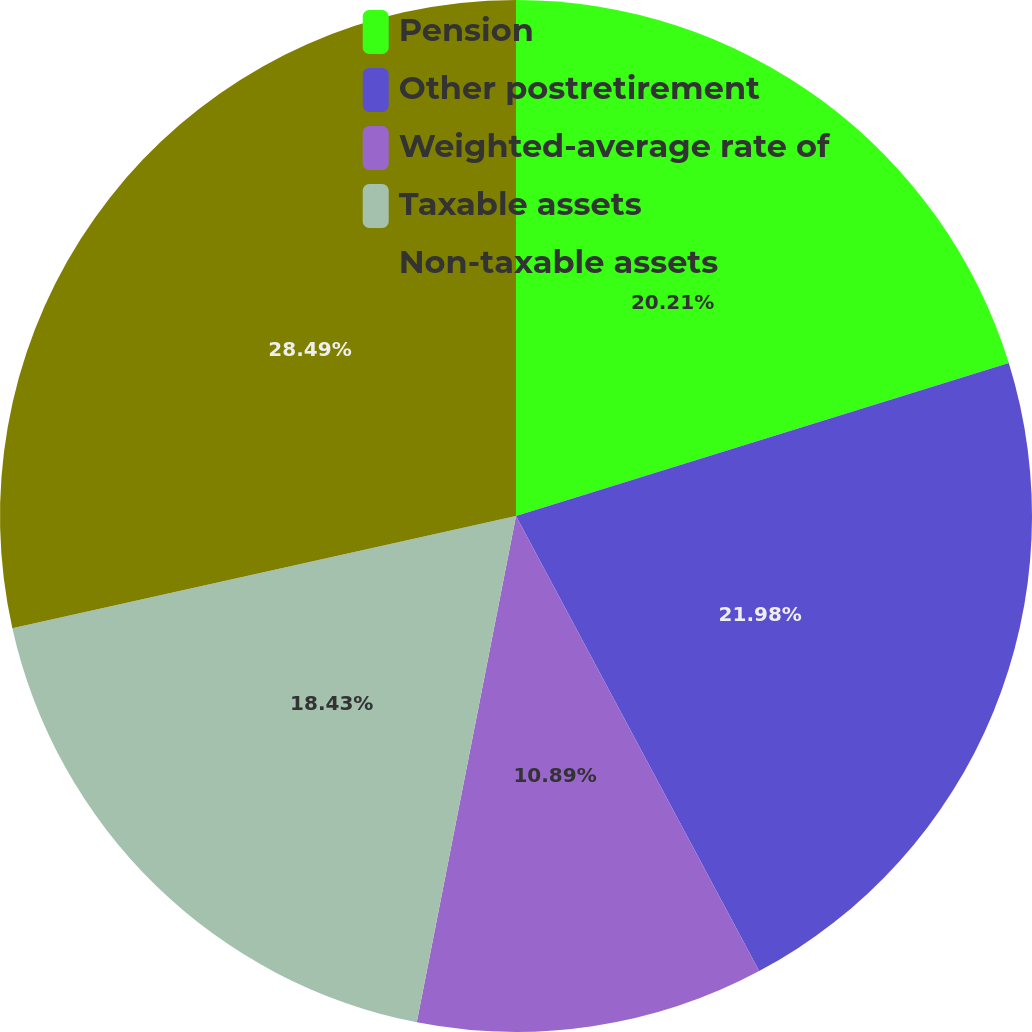<chart> <loc_0><loc_0><loc_500><loc_500><pie_chart><fcel>Pension<fcel>Other postretirement<fcel>Weighted-average rate of<fcel>Taxable assets<fcel>Non-taxable assets<nl><fcel>20.21%<fcel>21.98%<fcel>10.89%<fcel>18.43%<fcel>28.49%<nl></chart> 